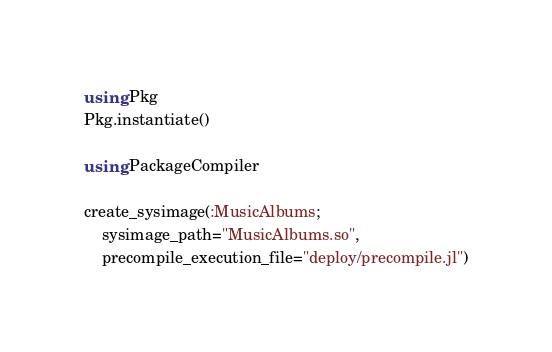<code> <loc_0><loc_0><loc_500><loc_500><_Julia_>using Pkg
Pkg.instantiate()

using PackageCompiler

create_sysimage(:MusicAlbums;
    sysimage_path="MusicAlbums.so",
    precompile_execution_file="deploy/precompile.jl")</code> 